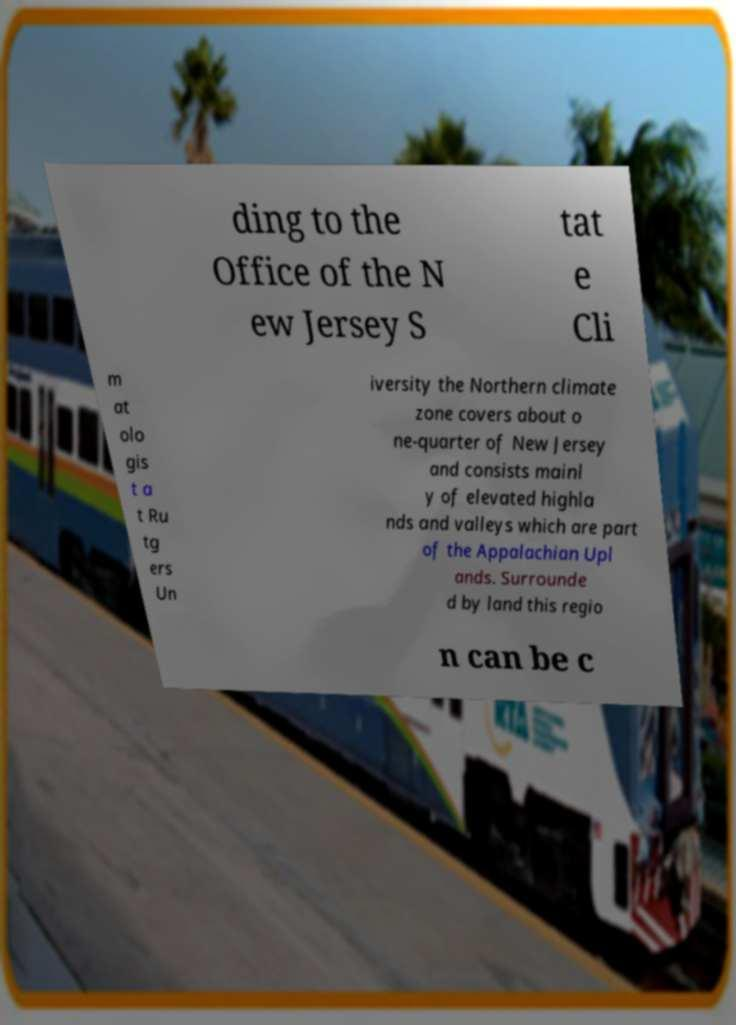Please identify and transcribe the text found in this image. ding to the Office of the N ew Jersey S tat e Cli m at olo gis t a t Ru tg ers Un iversity the Northern climate zone covers about o ne-quarter of New Jersey and consists mainl y of elevated highla nds and valleys which are part of the Appalachian Upl ands. Surrounde d by land this regio n can be c 